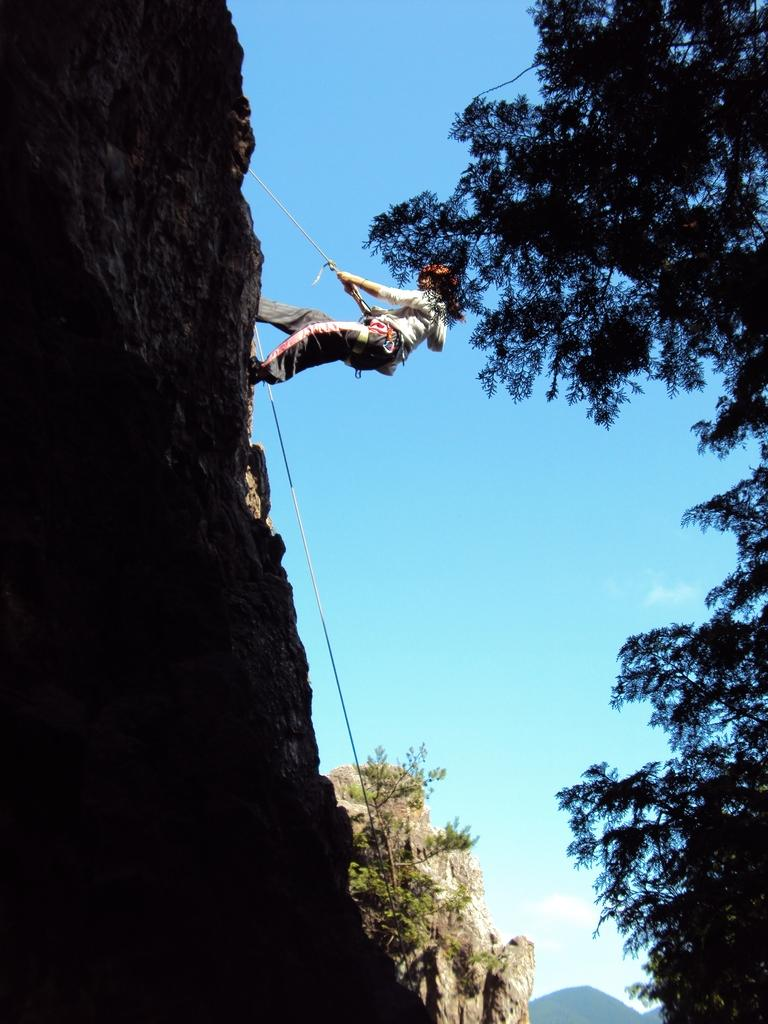What is the main subject of the image? There is a person in the image. What is the person doing in the image? The person is climbing a mountain. How is the person assisted in climbing the mountain? The person is using a rope for assistance. What can be seen in the background of the image? The background of the image is the sky. What type of humor can be seen in the image? There is no humor present in the image; it depicts a person climbing a mountain with a rope. What kind of board is visible in the image? There is no board present in the image. 